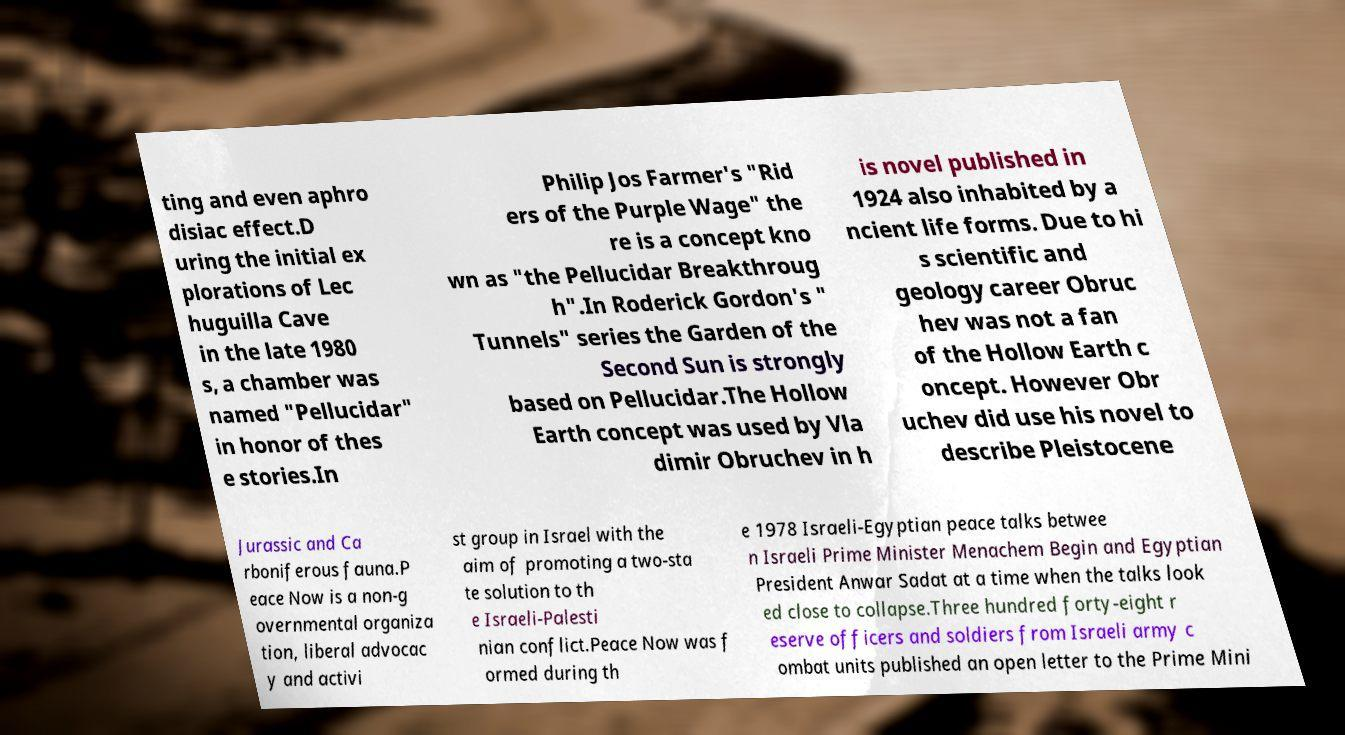Can you read and provide the text displayed in the image?This photo seems to have some interesting text. Can you extract and type it out for me? ting and even aphro disiac effect.D uring the initial ex plorations of Lec huguilla Cave in the late 1980 s, a chamber was named "Pellucidar" in honor of thes e stories.In Philip Jos Farmer's "Rid ers of the Purple Wage" the re is a concept kno wn as "the Pellucidar Breakthroug h".In Roderick Gordon's " Tunnels" series the Garden of the Second Sun is strongly based on Pellucidar.The Hollow Earth concept was used by Vla dimir Obruchev in h is novel published in 1924 also inhabited by a ncient life forms. Due to hi s scientific and geology career Obruc hev was not a fan of the Hollow Earth c oncept. However Obr uchev did use his novel to describe Pleistocene Jurassic and Ca rboniferous fauna.P eace Now is a non-g overnmental organiza tion, liberal advocac y and activi st group in Israel with the aim of promoting a two-sta te solution to th e Israeli-Palesti nian conflict.Peace Now was f ormed during th e 1978 Israeli-Egyptian peace talks betwee n Israeli Prime Minister Menachem Begin and Egyptian President Anwar Sadat at a time when the talks look ed close to collapse.Three hundred forty-eight r eserve officers and soldiers from Israeli army c ombat units published an open letter to the Prime Mini 